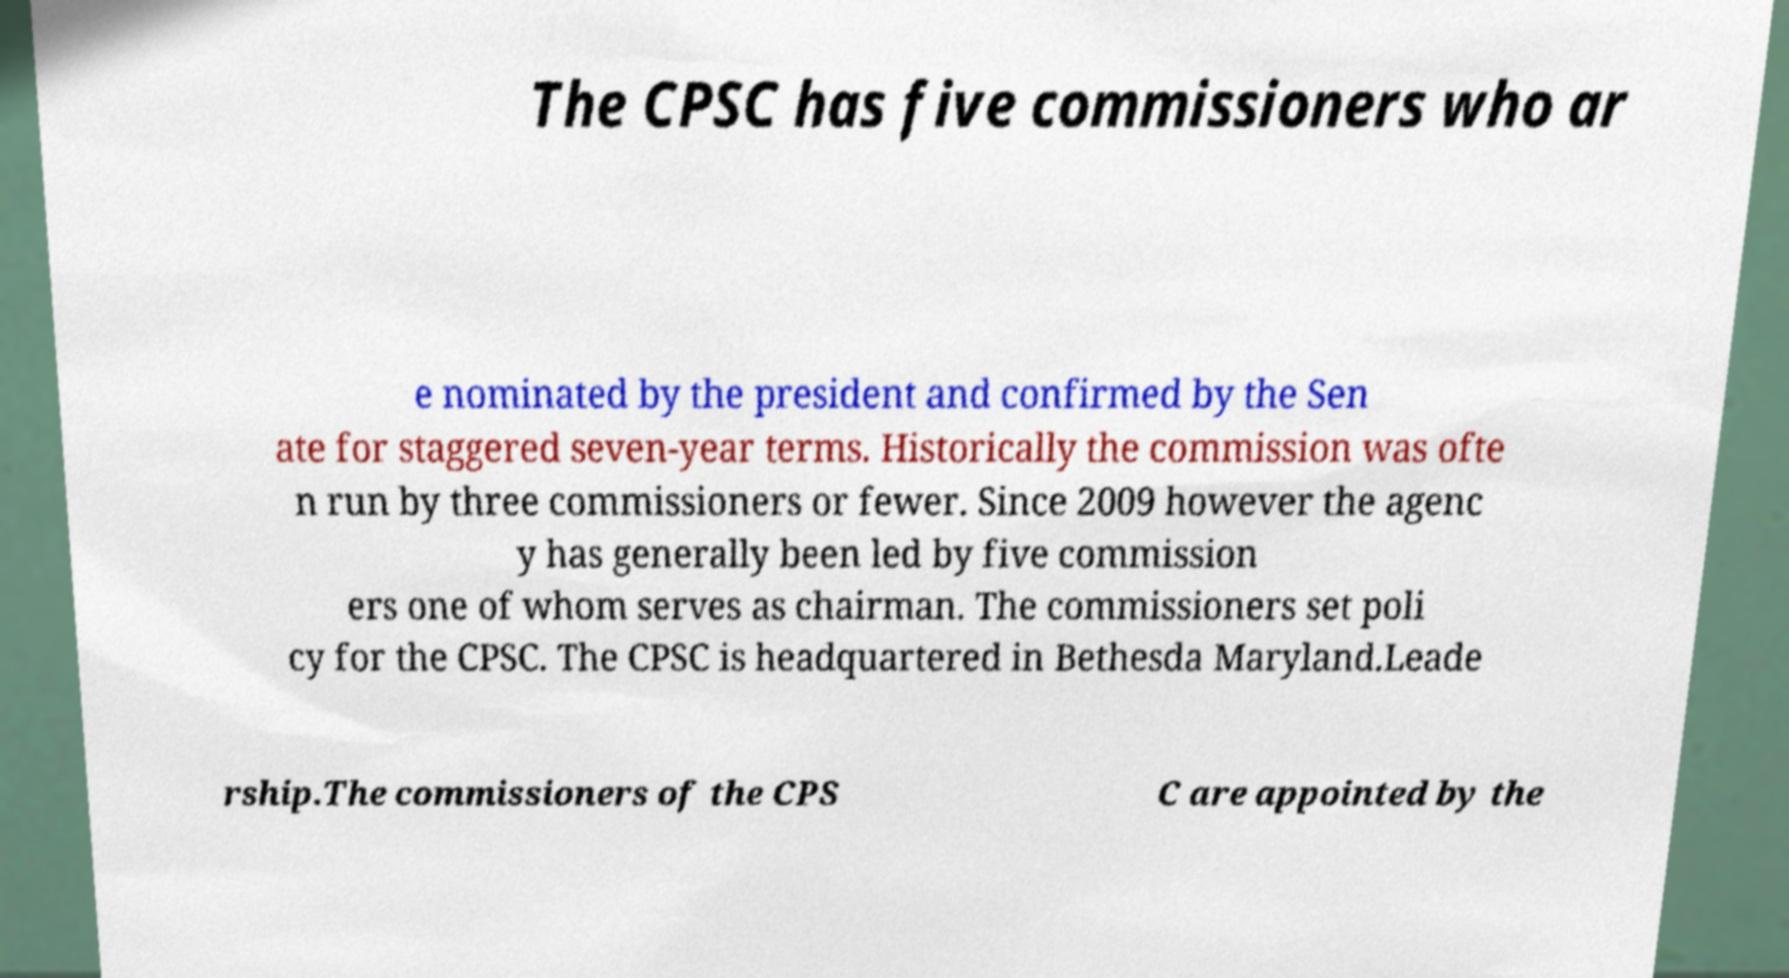Could you extract and type out the text from this image? The CPSC has five commissioners who ar e nominated by the president and confirmed by the Sen ate for staggered seven-year terms. Historically the commission was ofte n run by three commissioners or fewer. Since 2009 however the agenc y has generally been led by five commission ers one of whom serves as chairman. The commissioners set poli cy for the CPSC. The CPSC is headquartered in Bethesda Maryland.Leade rship.The commissioners of the CPS C are appointed by the 